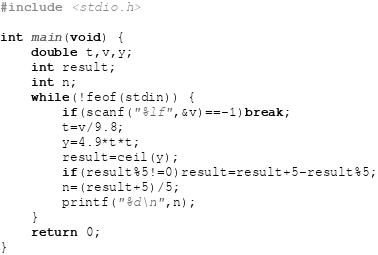<code> <loc_0><loc_0><loc_500><loc_500><_C_>#include <stdio.h>

int main(void) {
	double t,v,y;
	int result;
	int n;
	while(!feof(stdin)) {
		if(scanf("%lf",&v)==-1)break;
		t=v/9.8;
		y=4.9*t*t;
		result=ceil(y);
		if(result%5!=0)result=result+5-result%5;
		n=(result+5)/5;
		printf("%d\n",n);
	}
	return 0;
}</code> 